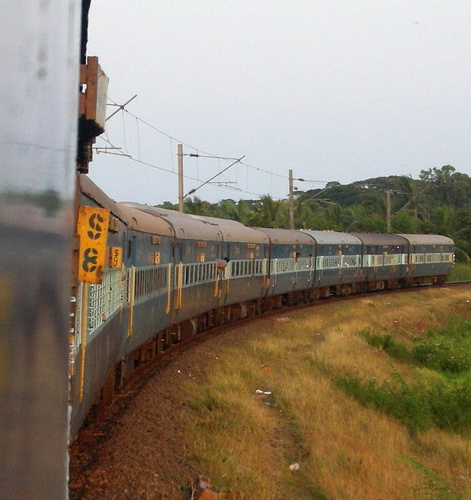Describe the objects in this image and their specific colors. I can see a train in lightgray, gray, black, and maroon tones in this image. 